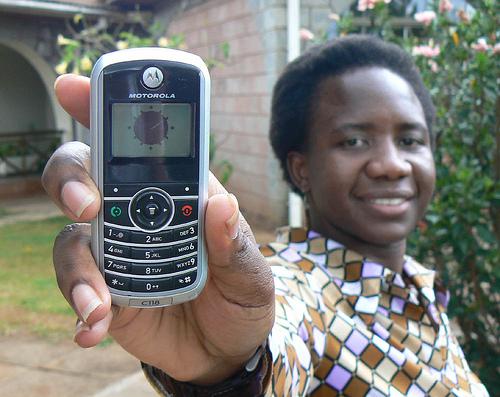Is this inside or outside?
Concise answer only. Outside. What type of phone is this?
Write a very short answer. Motorola. What color is the woman?
Answer briefly. Black. 